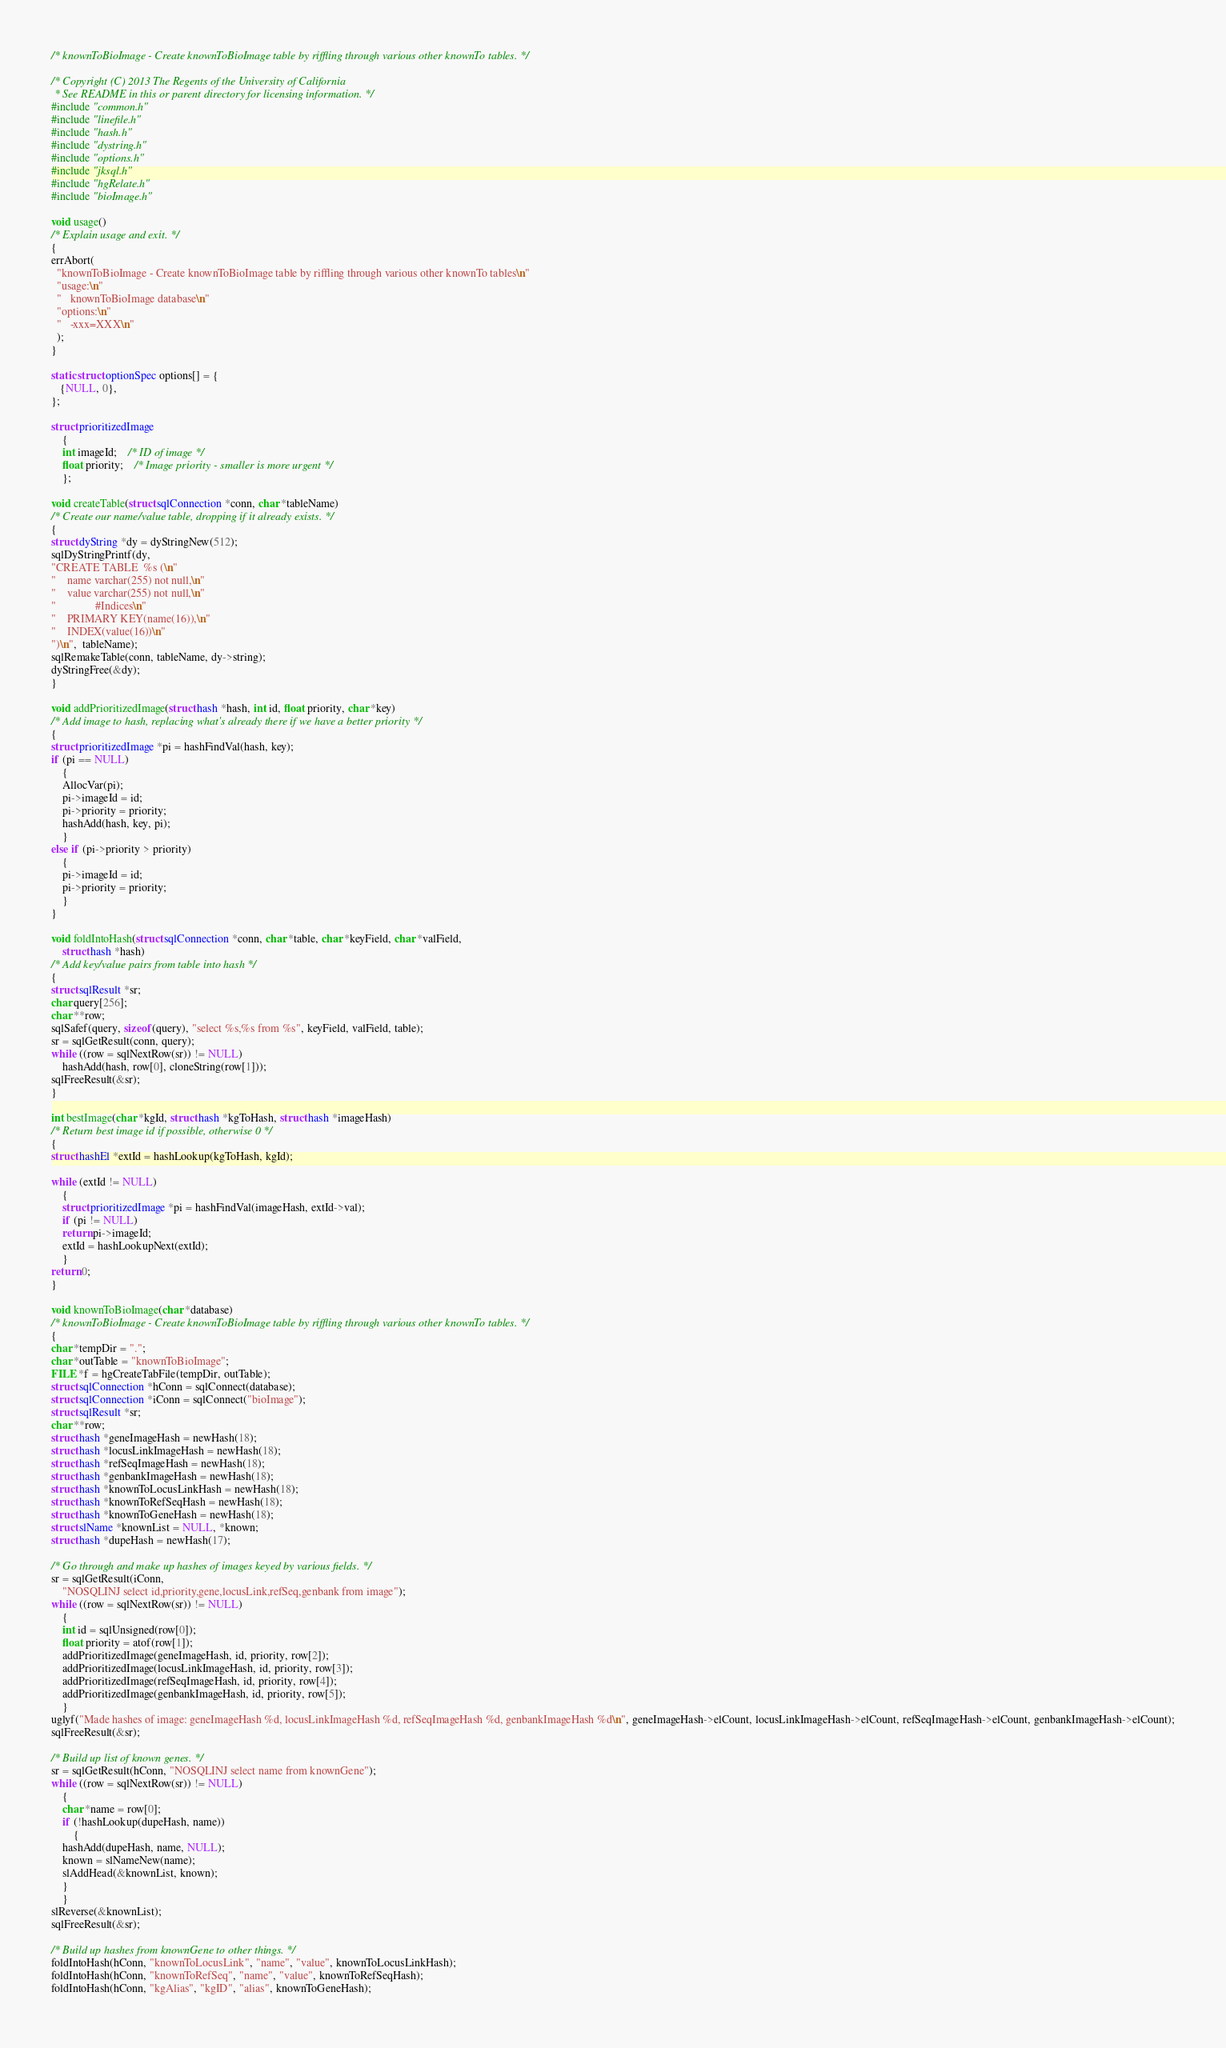<code> <loc_0><loc_0><loc_500><loc_500><_C_>/* knownToBioImage - Create knownToBioImage table by riffling through various other knownTo tables. */

/* Copyright (C) 2013 The Regents of the University of California 
 * See README in this or parent directory for licensing information. */
#include "common.h"
#include "linefile.h"
#include "hash.h"
#include "dystring.h"
#include "options.h"
#include "jksql.h"
#include "hgRelate.h"
#include "bioImage.h"

void usage()
/* Explain usage and exit. */
{
errAbort(
  "knownToBioImage - Create knownToBioImage table by riffling through various other knownTo tables\n"
  "usage:\n"
  "   knownToBioImage database\n"
  "options:\n"
  "   -xxx=XXX\n"
  );
}

static struct optionSpec options[] = {
   {NULL, 0},
};

struct prioritizedImage 
    {
    int imageId;	/* ID of image */
    float priority;	/* Image priority - smaller is more urgent */
    };

void createTable(struct sqlConnection *conn, char *tableName)
/* Create our name/value table, dropping if it already exists. */
{
struct dyString *dy = dyStringNew(512);
sqlDyStringPrintf(dy, 
"CREATE TABLE  %s (\n"
"    name varchar(255) not null,\n"
"    value varchar(255) not null,\n"
"              #Indices\n"
"    PRIMARY KEY(name(16)),\n"
"    INDEX(value(16))\n"
")\n",  tableName);
sqlRemakeTable(conn, tableName, dy->string);
dyStringFree(&dy);
}

void addPrioritizedImage(struct hash *hash, int id, float priority, char *key)
/* Add image to hash, replacing what's already there if we have a better priority */
{
struct prioritizedImage *pi = hashFindVal(hash, key);
if (pi == NULL)
    {
    AllocVar(pi);
    pi->imageId = id;
    pi->priority = priority;
    hashAdd(hash, key, pi);
    }
else if (pi->priority > priority)
    {
    pi->imageId = id;
    pi->priority = priority;
    }
}

void foldIntoHash(struct sqlConnection *conn, char *table, char *keyField, char *valField,
	struct hash *hash)
/* Add key/value pairs from table into hash */
{
struct sqlResult *sr;
char query[256];
char **row;
sqlSafef(query, sizeof(query), "select %s,%s from %s", keyField, valField, table);
sr = sqlGetResult(conn, query);
while ((row = sqlNextRow(sr)) != NULL)
    hashAdd(hash, row[0], cloneString(row[1]));
sqlFreeResult(&sr);
}

int bestImage(char *kgId, struct hash *kgToHash, struct hash *imageHash)
/* Return best image id if possible, otherwise 0 */
{
struct hashEl *extId = hashLookup(kgToHash, kgId);

while (extId != NULL)
    {
    struct prioritizedImage *pi = hashFindVal(imageHash, extId->val);
    if (pi != NULL)
	return pi->imageId;
    extId = hashLookupNext(extId);
    }
return 0;
}

void knownToBioImage(char *database)
/* knownToBioImage - Create knownToBioImage table by riffling through various other knownTo tables. */
{
char *tempDir = ".";
char *outTable = "knownToBioImage";
FILE *f = hgCreateTabFile(tempDir, outTable);
struct sqlConnection *hConn = sqlConnect(database);
struct sqlConnection *iConn = sqlConnect("bioImage");
struct sqlResult *sr;
char **row;
struct hash *geneImageHash = newHash(18);
struct hash *locusLinkImageHash = newHash(18);
struct hash *refSeqImageHash = newHash(18);
struct hash *genbankImageHash = newHash(18);
struct hash *knownToLocusLinkHash = newHash(18);
struct hash *knownToRefSeqHash = newHash(18);
struct hash *knownToGeneHash = newHash(18);
struct slName *knownList = NULL, *known;
struct hash *dupeHash = newHash(17);

/* Go through and make up hashes of images keyed by various fields. */
sr = sqlGetResult(iConn, 
	"NOSQLINJ select id,priority,gene,locusLink,refSeq,genbank from image");
while ((row = sqlNextRow(sr)) != NULL)
    {
    int id = sqlUnsigned(row[0]);
    float priority = atof(row[1]);
    addPrioritizedImage(geneImageHash, id, priority, row[2]);
    addPrioritizedImage(locusLinkImageHash, id, priority, row[3]);
    addPrioritizedImage(refSeqImageHash, id, priority, row[4]);
    addPrioritizedImage(genbankImageHash, id, priority, row[5]);
    }
uglyf("Made hashes of image: geneImageHash %d, locusLinkImageHash %d, refSeqImageHash %d, genbankImageHash %d\n", geneImageHash->elCount, locusLinkImageHash->elCount, refSeqImageHash->elCount, genbankImageHash->elCount);
sqlFreeResult(&sr);

/* Build up list of known genes. */
sr = sqlGetResult(hConn, "NOSQLINJ select name from knownGene");
while ((row = sqlNextRow(sr)) != NULL)
    {
    char *name = row[0];
    if (!hashLookup(dupeHash, name))
        {
	hashAdd(dupeHash, name, NULL);
	known = slNameNew(name);
	slAddHead(&knownList, known);
	}
    }
slReverse(&knownList);
sqlFreeResult(&sr);

/* Build up hashes from knownGene to other things. */
foldIntoHash(hConn, "knownToLocusLink", "name", "value", knownToLocusLinkHash);
foldIntoHash(hConn, "knownToRefSeq", "name", "value", knownToRefSeqHash);
foldIntoHash(hConn, "kgAlias", "kgID", "alias", knownToGeneHash);</code> 